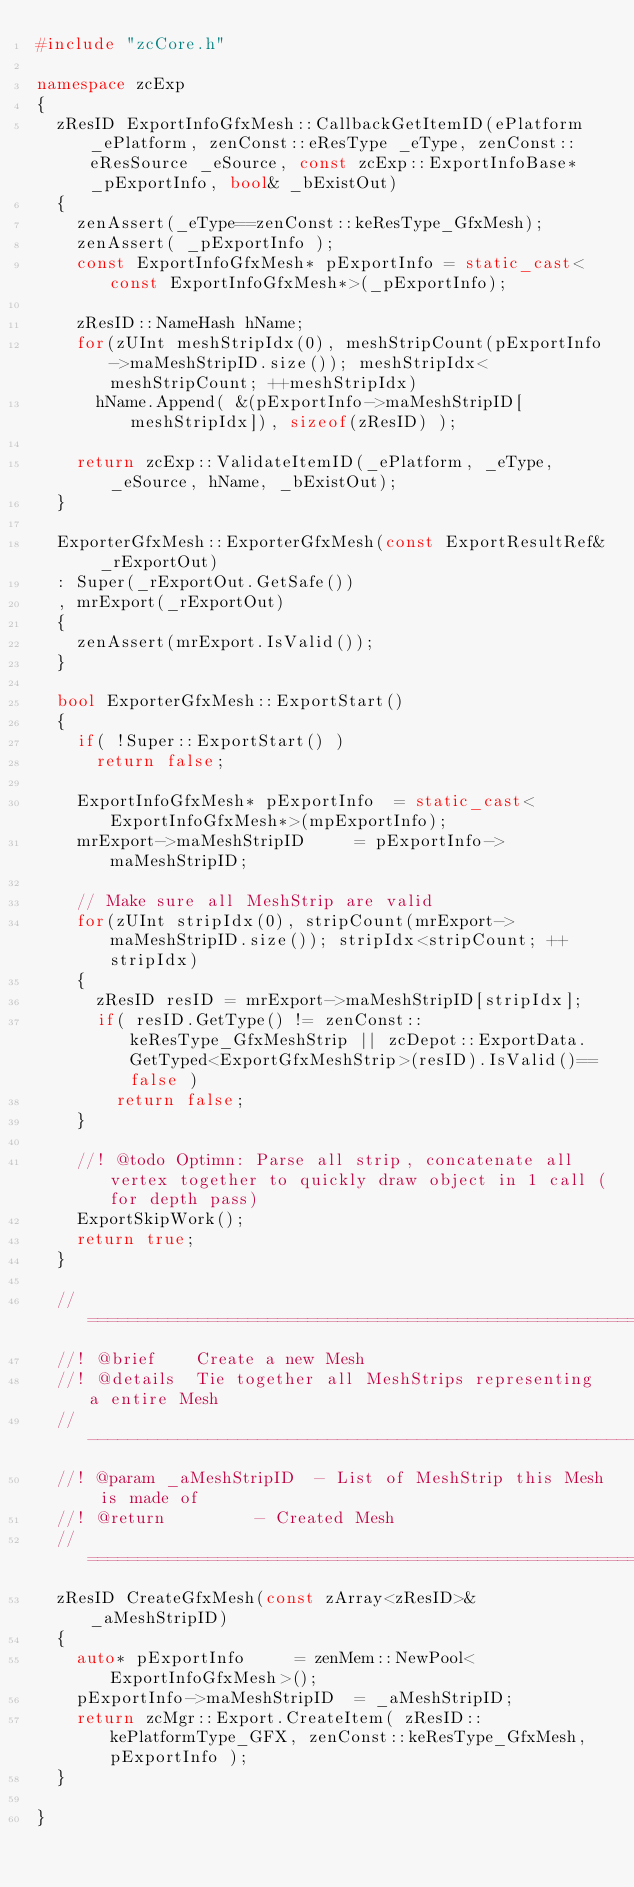Convert code to text. <code><loc_0><loc_0><loc_500><loc_500><_C++_>#include "zcCore.h"

namespace zcExp
{
	zResID ExportInfoGfxMesh::CallbackGetItemID(ePlatform _ePlatform, zenConst::eResType _eType, zenConst::eResSource _eSource, const zcExp::ExportInfoBase* _pExportInfo, bool& _bExistOut)
	{
		zenAssert(_eType==zenConst::keResType_GfxMesh);
		zenAssert( _pExportInfo );
		const ExportInfoGfxMesh* pExportInfo = static_cast<const ExportInfoGfxMesh*>(_pExportInfo);

		zResID::NameHash hName;
		for(zUInt meshStripIdx(0), meshStripCount(pExportInfo->maMeshStripID.size()); meshStripIdx<meshStripCount; ++meshStripIdx)
			hName.Append( &(pExportInfo->maMeshStripID[meshStripIdx]), sizeof(zResID) );

		return zcExp::ValidateItemID(_ePlatform, _eType, _eSource, hName, _bExistOut);
	}

	ExporterGfxMesh::ExporterGfxMesh(const ExportResultRef& _rExportOut)
	: Super(_rExportOut.GetSafe())
	, mrExport(_rExportOut)
	{
		zenAssert(mrExport.IsValid());
	}

	bool ExporterGfxMesh::ExportStart()
	{
		if( !Super::ExportStart() )
			return false;
	
		ExportInfoGfxMesh* pExportInfo	= static_cast<ExportInfoGfxMesh*>(mpExportInfo);
		mrExport->maMeshStripID			= pExportInfo->maMeshStripID;

		// Make sure all MeshStrip are valid
		for(zUInt stripIdx(0), stripCount(mrExport->maMeshStripID.size()); stripIdx<stripCount; ++stripIdx)
		{
			zResID resID = mrExport->maMeshStripID[stripIdx];
			if( resID.GetType() != zenConst::keResType_GfxMeshStrip || zcDepot::ExportData.GetTyped<ExportGfxMeshStrip>(resID).IsValid()==false )
				return false;
		}

		//! @todo Optimn: Parse all strip, concatenate all vertex together to quickly draw object in 1 call (for depth pass)
		ExportSkipWork();
		return true;
	}

	//=================================================================================================
	//! @brief		Create a new Mesh
	//! @details	Tie together all MeshStrips representing a entire Mesh
	//-------------------------------------------------------------------------------------------------
	//! @param _aMeshStripID	- List of MeshStrip this Mesh is made of
	//! @return 				- Created Mesh
	//=================================================================================================
	zResID CreateGfxMesh(const zArray<zResID>& _aMeshStripID)
	{
		auto* pExportInfo			= zenMem::NewPool<ExportInfoGfxMesh>();
		pExportInfo->maMeshStripID	= _aMeshStripID;	
		return zcMgr::Export.CreateItem( zResID::kePlatformType_GFX, zenConst::keResType_GfxMesh, pExportInfo );
	}

}

</code> 